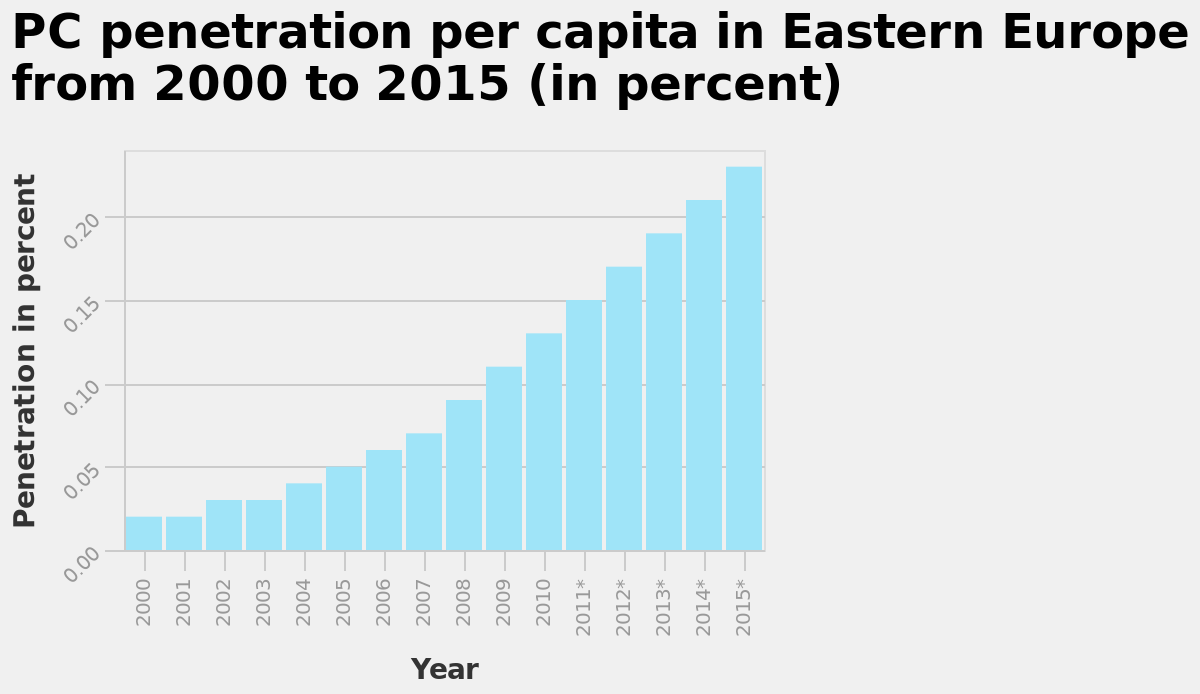<image>
What does PC penetration per capita mean? PC penetration per capita refers to the number of personal computers (PCs) in use per person in a particular region, in this case, Eastern Europe. What is the time period covered by the graph? The graph covers the years from 2000 to 2015. 